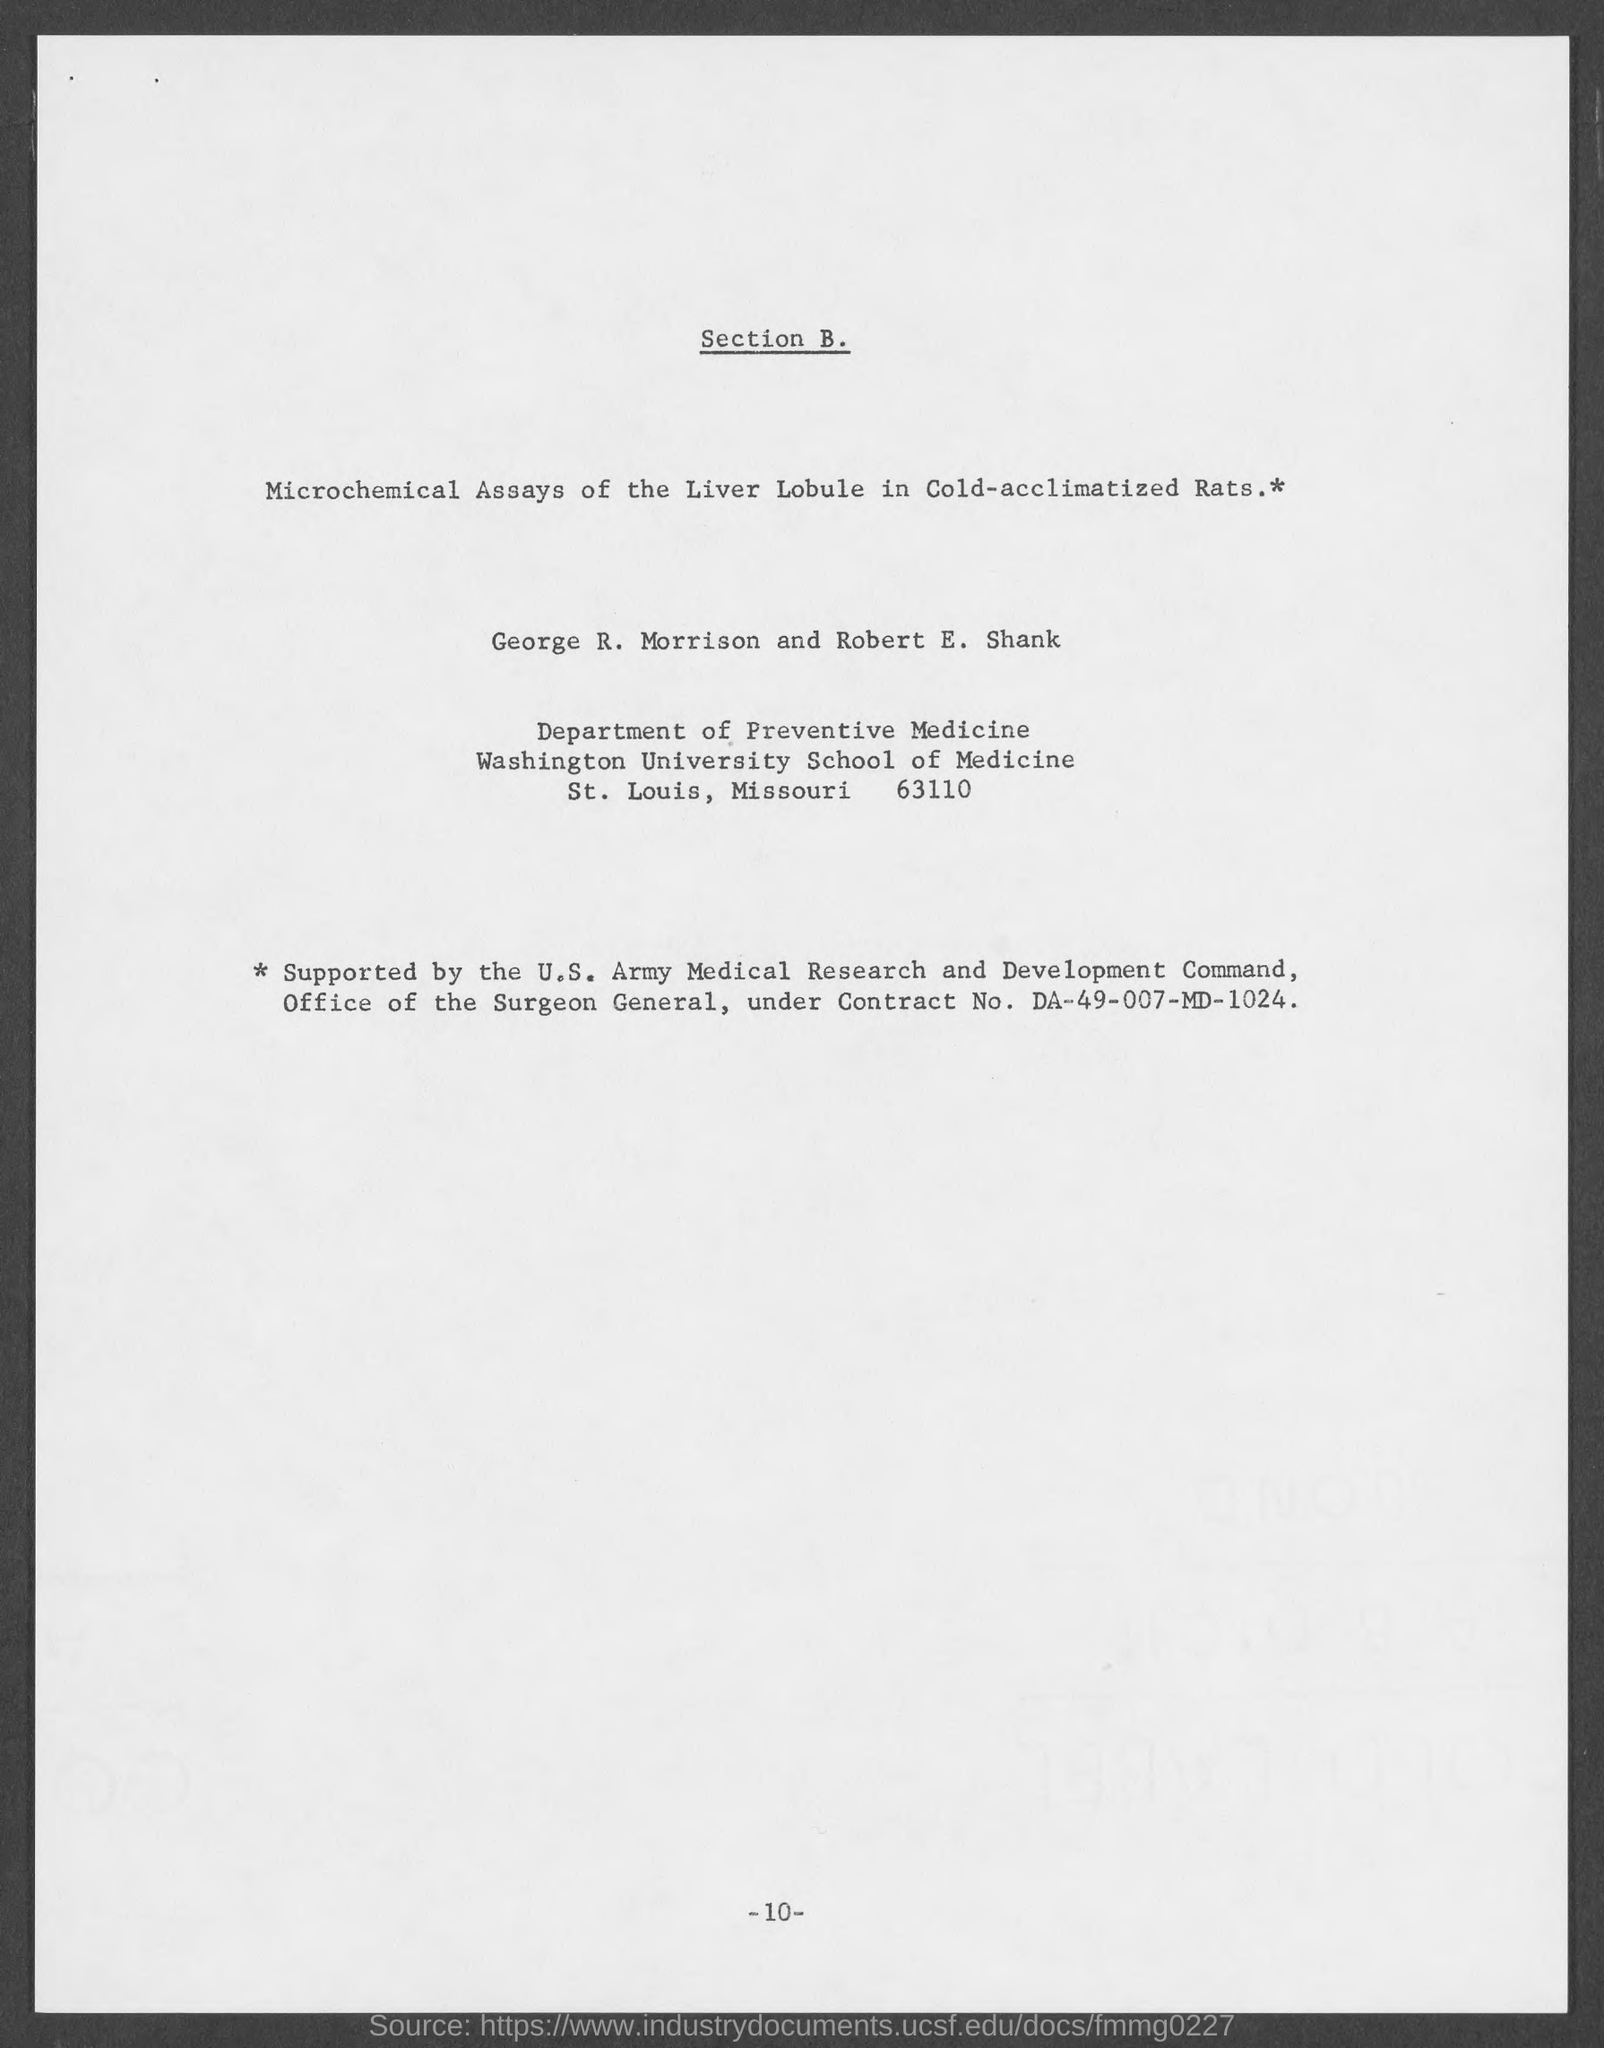To which university does robert e.shank ?
Keep it short and to the point. Washington University School of Medicine. What is the page number at bottom of the page?
Provide a succinct answer. -10-. 